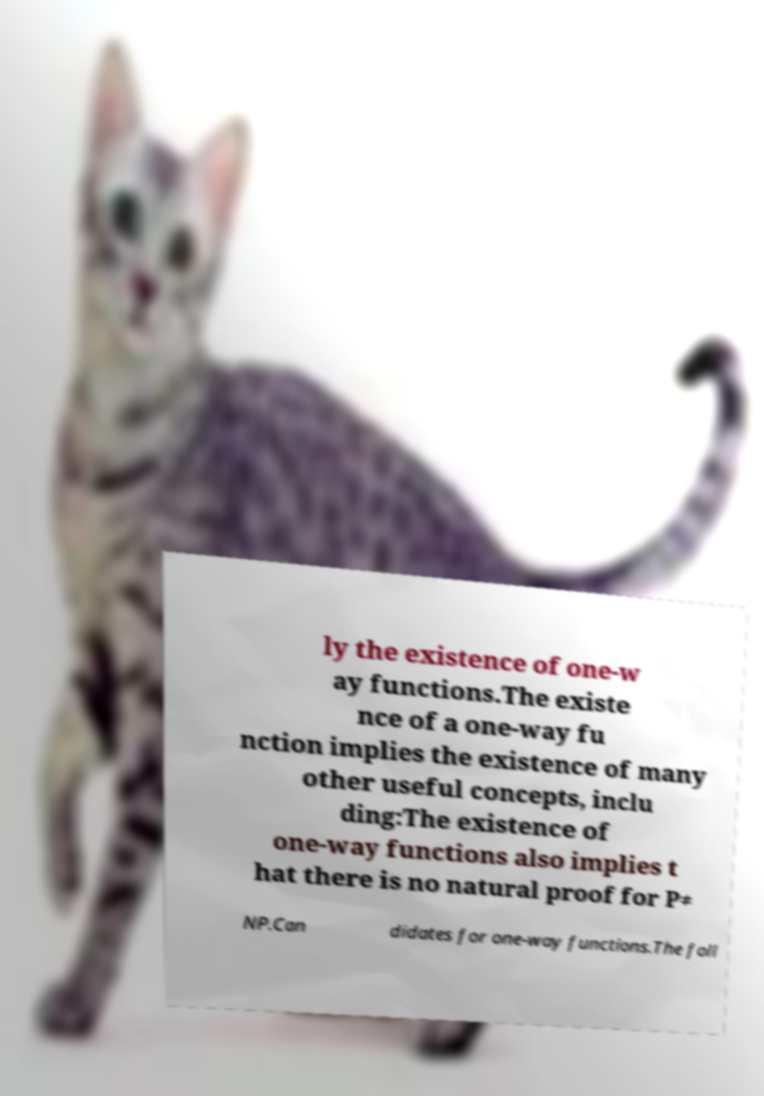Please identify and transcribe the text found in this image. ly the existence of one-w ay functions.The existe nce of a one-way fu nction implies the existence of many other useful concepts, inclu ding:The existence of one-way functions also implies t hat there is no natural proof for P≠ NP.Can didates for one-way functions.The foll 